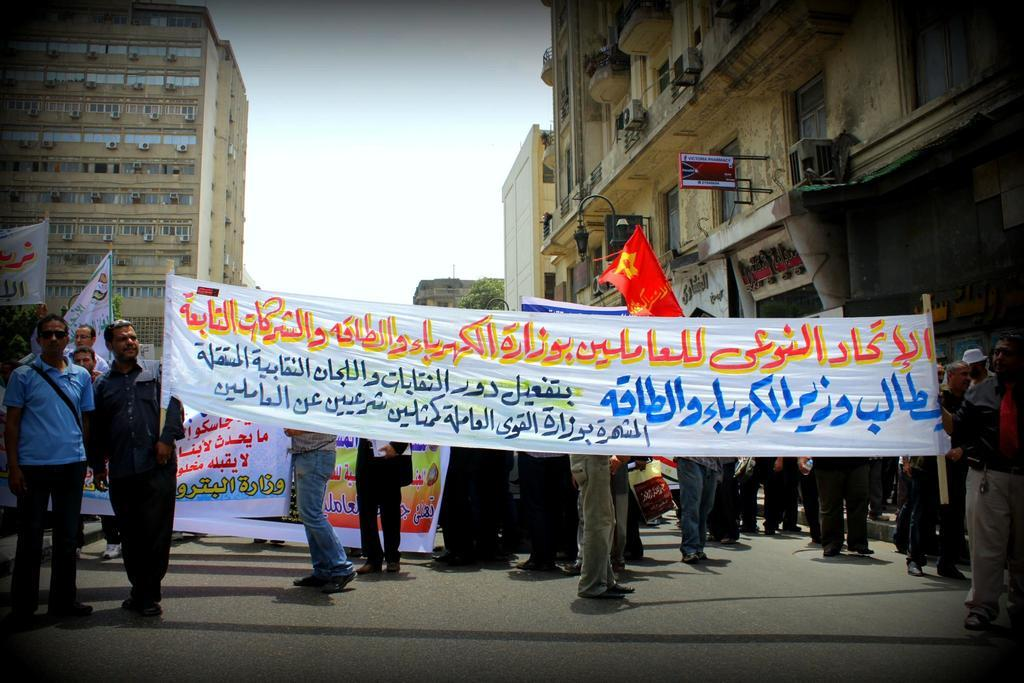What type of structures can be seen in the image? There are buildings in the image. What architectural features can be observed on the buildings? Windows are visible in the image. What type of vegetation is present in the image? There are trees in the image. What type of street furniture is present in the image? There is a light pole in the image. What are the people in the image holding? The people in the image are holding flags and banners. What is the color of the sky in the image? The sky appears to be white in color. What type of net can be seen in the image? There is no net present in the image. What type of fruit is hanging from the light pole in the image? There is no fruit hanging from the light pole in the image. 